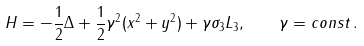Convert formula to latex. <formula><loc_0><loc_0><loc_500><loc_500>H = - \frac { 1 } { 2 } \Delta + \frac { 1 } { 2 } { \gamma } ^ { 2 } ( x ^ { 2 } + y ^ { 2 } ) + \gamma \sigma _ { 3 } L _ { 3 } , \quad \gamma = c o n s t \, .</formula> 